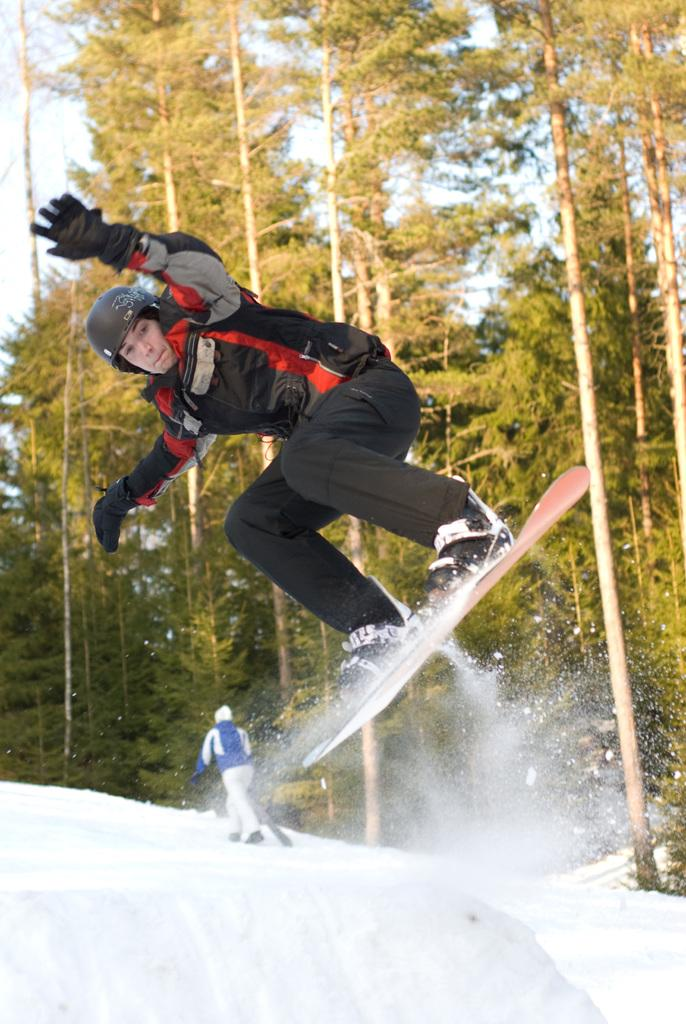What is the primary feature of the foreground in the image? There is snow in the foreground of the image. What is the person in the image doing? A: The person is skating in the image. Can you describe the background of the image? There are many trees in the background of the image. What part of the natural environment is visible in the image? The sky is visible in the image. What type of chalk is the person using to draw on the stage in the image? There is no chalk or stage present in the image. How much payment is the person receiving for their performance in the image? There is no performance or payment mentioned in the image. 